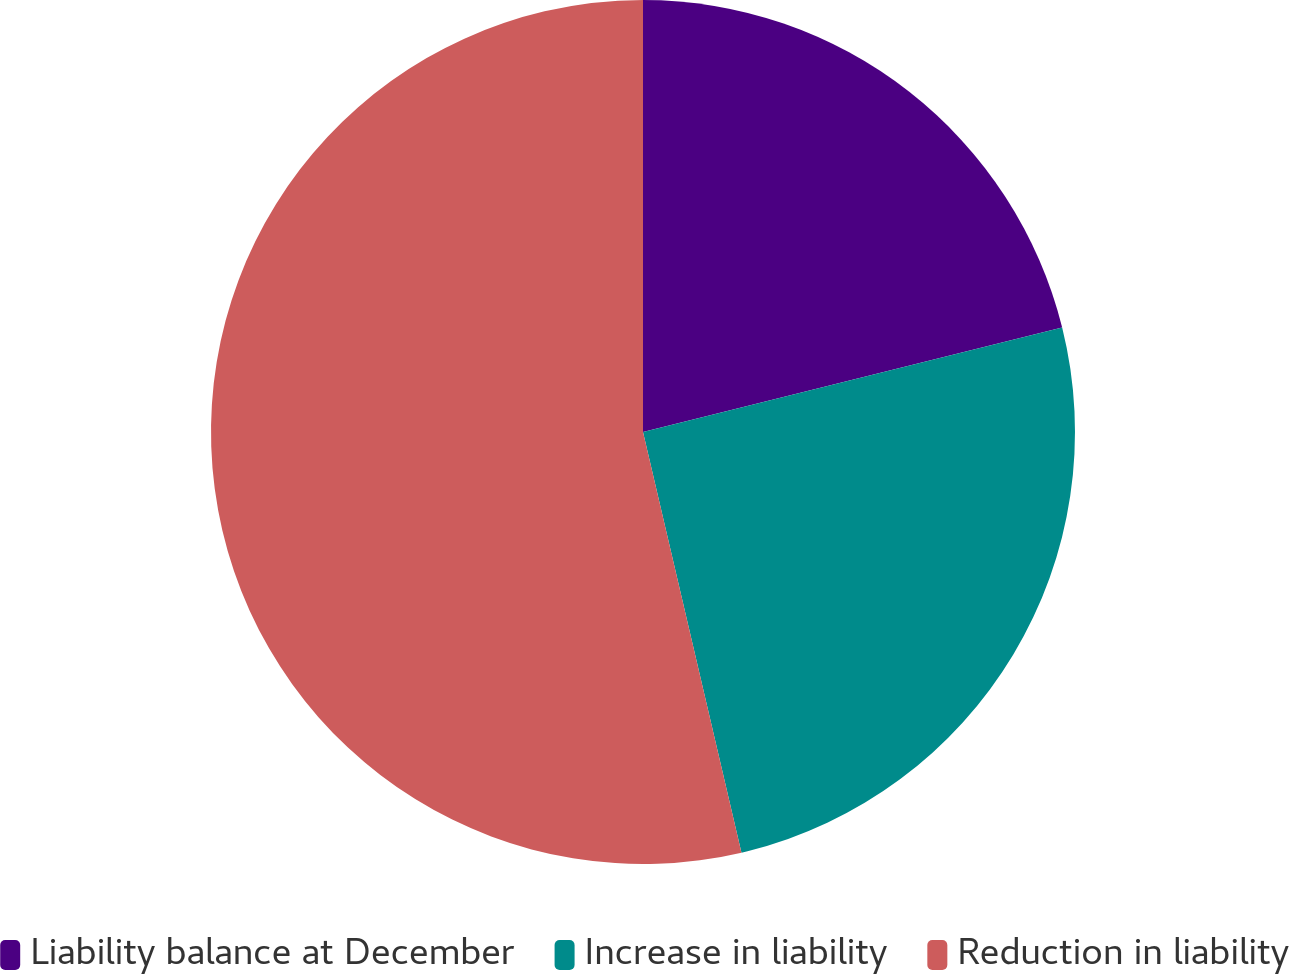<chart> <loc_0><loc_0><loc_500><loc_500><pie_chart><fcel>Liability balance at December<fcel>Increase in liability<fcel>Reduction in liability<nl><fcel>21.11%<fcel>25.23%<fcel>53.66%<nl></chart> 